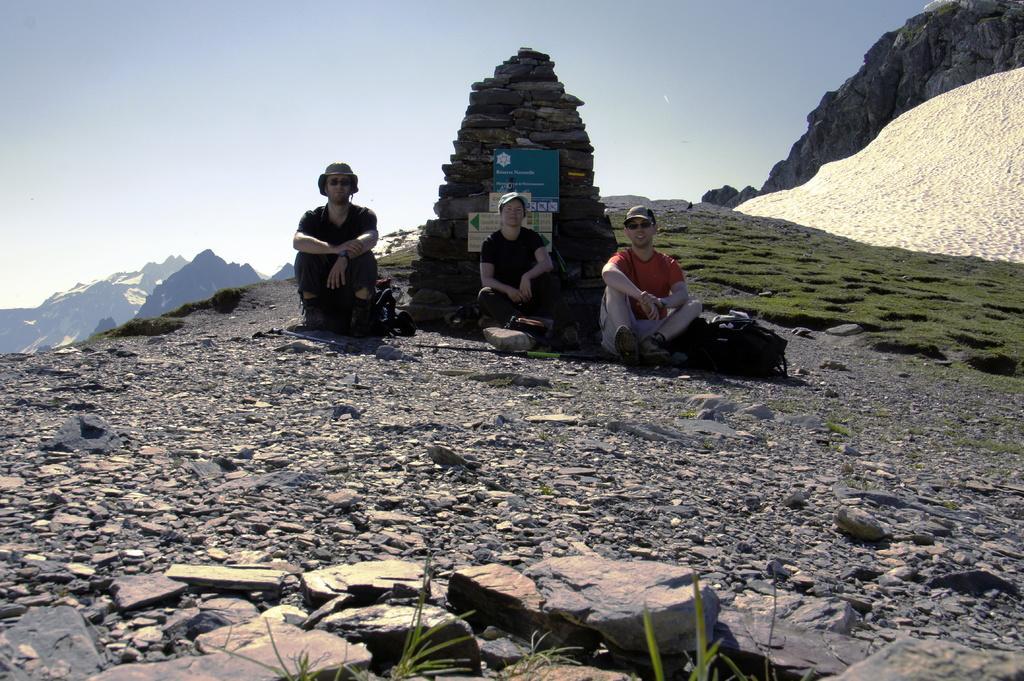In one or two sentences, can you explain what this image depicts? In this image, we can see three persons sitting, there is grass on the ground at some area, there is a mountain, at the top there is a sky which is cloudy. 